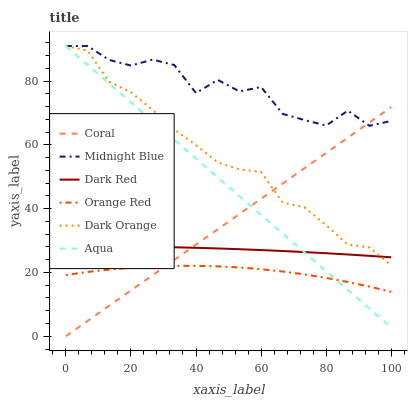Does Orange Red have the minimum area under the curve?
Answer yes or no. Yes. Does Midnight Blue have the maximum area under the curve?
Answer yes or no. Yes. Does Dark Red have the minimum area under the curve?
Answer yes or no. No. Does Dark Red have the maximum area under the curve?
Answer yes or no. No. Is Coral the smoothest?
Answer yes or no. Yes. Is Midnight Blue the roughest?
Answer yes or no. Yes. Is Dark Red the smoothest?
Answer yes or no. No. Is Dark Red the roughest?
Answer yes or no. No. Does Coral have the lowest value?
Answer yes or no. Yes. Does Dark Red have the lowest value?
Answer yes or no. No. Does Aqua have the highest value?
Answer yes or no. Yes. Does Dark Red have the highest value?
Answer yes or no. No. Is Orange Red less than Midnight Blue?
Answer yes or no. Yes. Is Dark Orange greater than Orange Red?
Answer yes or no. Yes. Does Midnight Blue intersect Aqua?
Answer yes or no. Yes. Is Midnight Blue less than Aqua?
Answer yes or no. No. Is Midnight Blue greater than Aqua?
Answer yes or no. No. Does Orange Red intersect Midnight Blue?
Answer yes or no. No. 